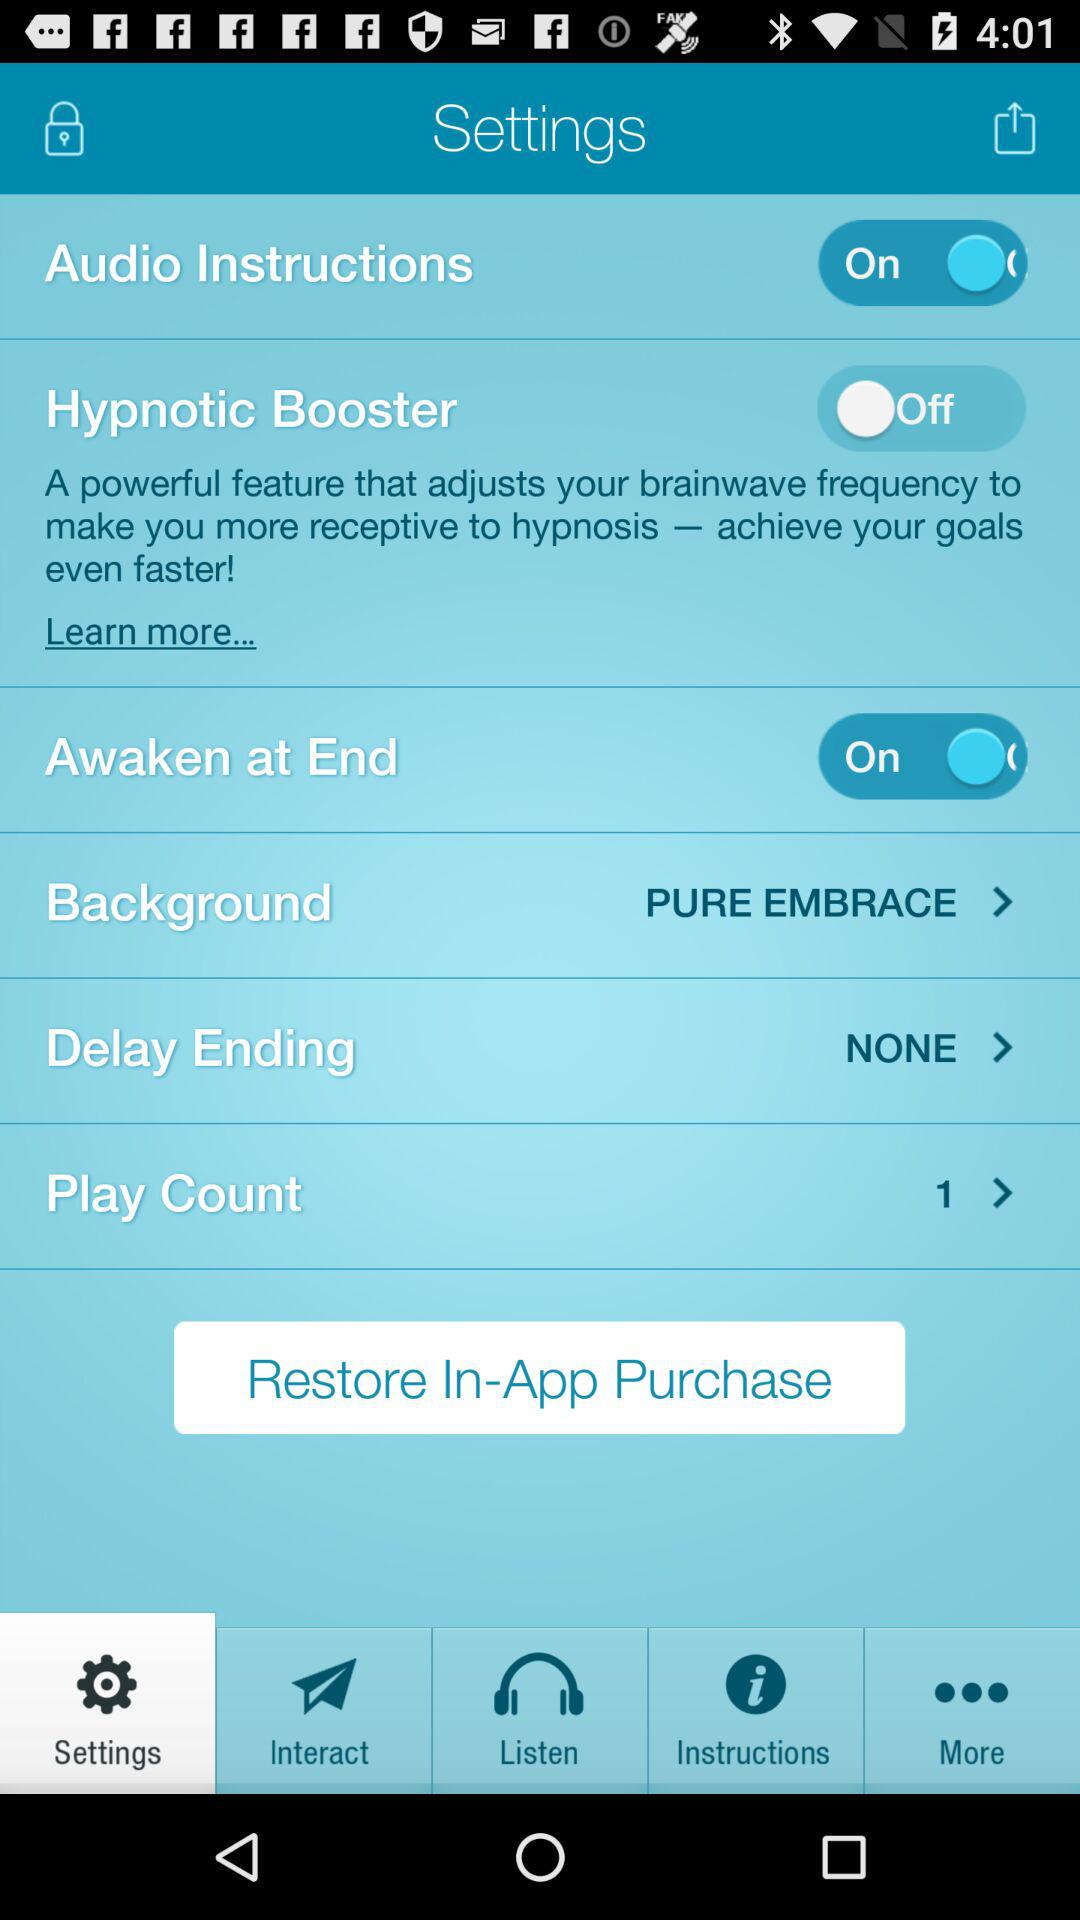How many items have a text label?
Answer the question using a single word or phrase. 6 